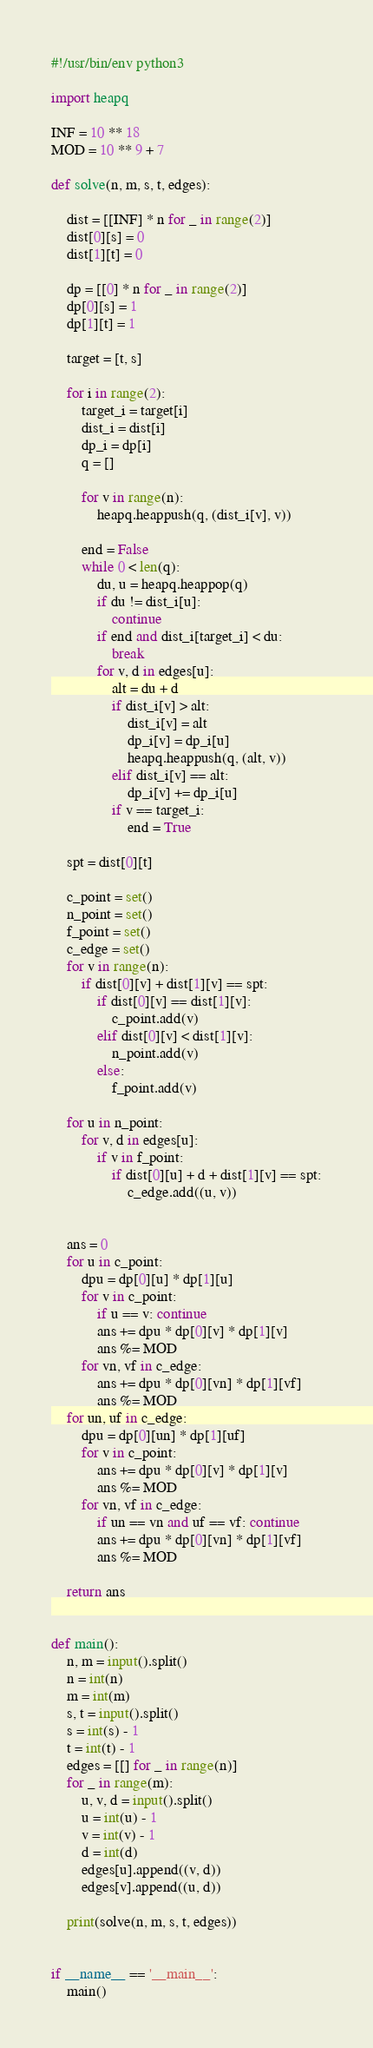Convert code to text. <code><loc_0><loc_0><loc_500><loc_500><_Python_>#!/usr/bin/env python3

import heapq

INF = 10 ** 18
MOD = 10 ** 9 + 7

def solve(n, m, s, t, edges):

    dist = [[INF] * n for _ in range(2)]
    dist[0][s] = 0
    dist[1][t] = 0

    dp = [[0] * n for _ in range(2)]
    dp[0][s] = 1
    dp[1][t] = 1

    target = [t, s]

    for i in range(2):
        target_i = target[i]
        dist_i = dist[i]
        dp_i = dp[i]
        q = []

        for v in range(n):
            heapq.heappush(q, (dist_i[v], v))

        end = False
        while 0 < len(q):
            du, u = heapq.heappop(q)
            if du != dist_i[u]:
                continue
            if end and dist_i[target_i] < du:
                break
            for v, d in edges[u]:
                alt = du + d
                if dist_i[v] > alt:
                    dist_i[v] = alt
                    dp_i[v] = dp_i[u]
                    heapq.heappush(q, (alt, v))
                elif dist_i[v] == alt:
                    dp_i[v] += dp_i[u]
                if v == target_i:
                    end = True

    spt = dist[0][t]

    c_point = set()
    n_point = set()
    f_point = set()
    c_edge = set()
    for v in range(n):
        if dist[0][v] + dist[1][v] == spt:
            if dist[0][v] == dist[1][v]:
                c_point.add(v)
            elif dist[0][v] < dist[1][v]:
                n_point.add(v)
            else:
                f_point.add(v)

    for u in n_point:
        for v, d in edges[u]:
            if v in f_point:
                if dist[0][u] + d + dist[1][v] == spt:
                    c_edge.add((u, v))


    ans = 0
    for u in c_point:
        dpu = dp[0][u] * dp[1][u]
        for v in c_point:
            if u == v: continue
            ans += dpu * dp[0][v] * dp[1][v]
            ans %= MOD
        for vn, vf in c_edge:
            ans += dpu * dp[0][vn] * dp[1][vf]
            ans %= MOD
    for un, uf in c_edge:
        dpu = dp[0][un] * dp[1][uf]
        for v in c_point:
            ans += dpu * dp[0][v] * dp[1][v]
            ans %= MOD
        for vn, vf in c_edge:
            if un == vn and uf == vf: continue
            ans += dpu * dp[0][vn] * dp[1][vf]
            ans %= MOD

    return ans


def main():
    n, m = input().split()
    n = int(n)
    m = int(m)
    s, t = input().split()
    s = int(s) - 1
    t = int(t) - 1
    edges = [[] for _ in range(n)]
    for _ in range(m):
        u, v, d = input().split()
        u = int(u) - 1
        v = int(v) - 1
        d = int(d)
        edges[u].append((v, d))
        edges[v].append((u, d))

    print(solve(n, m, s, t, edges))


if __name__ == '__main__':
    main()

</code> 